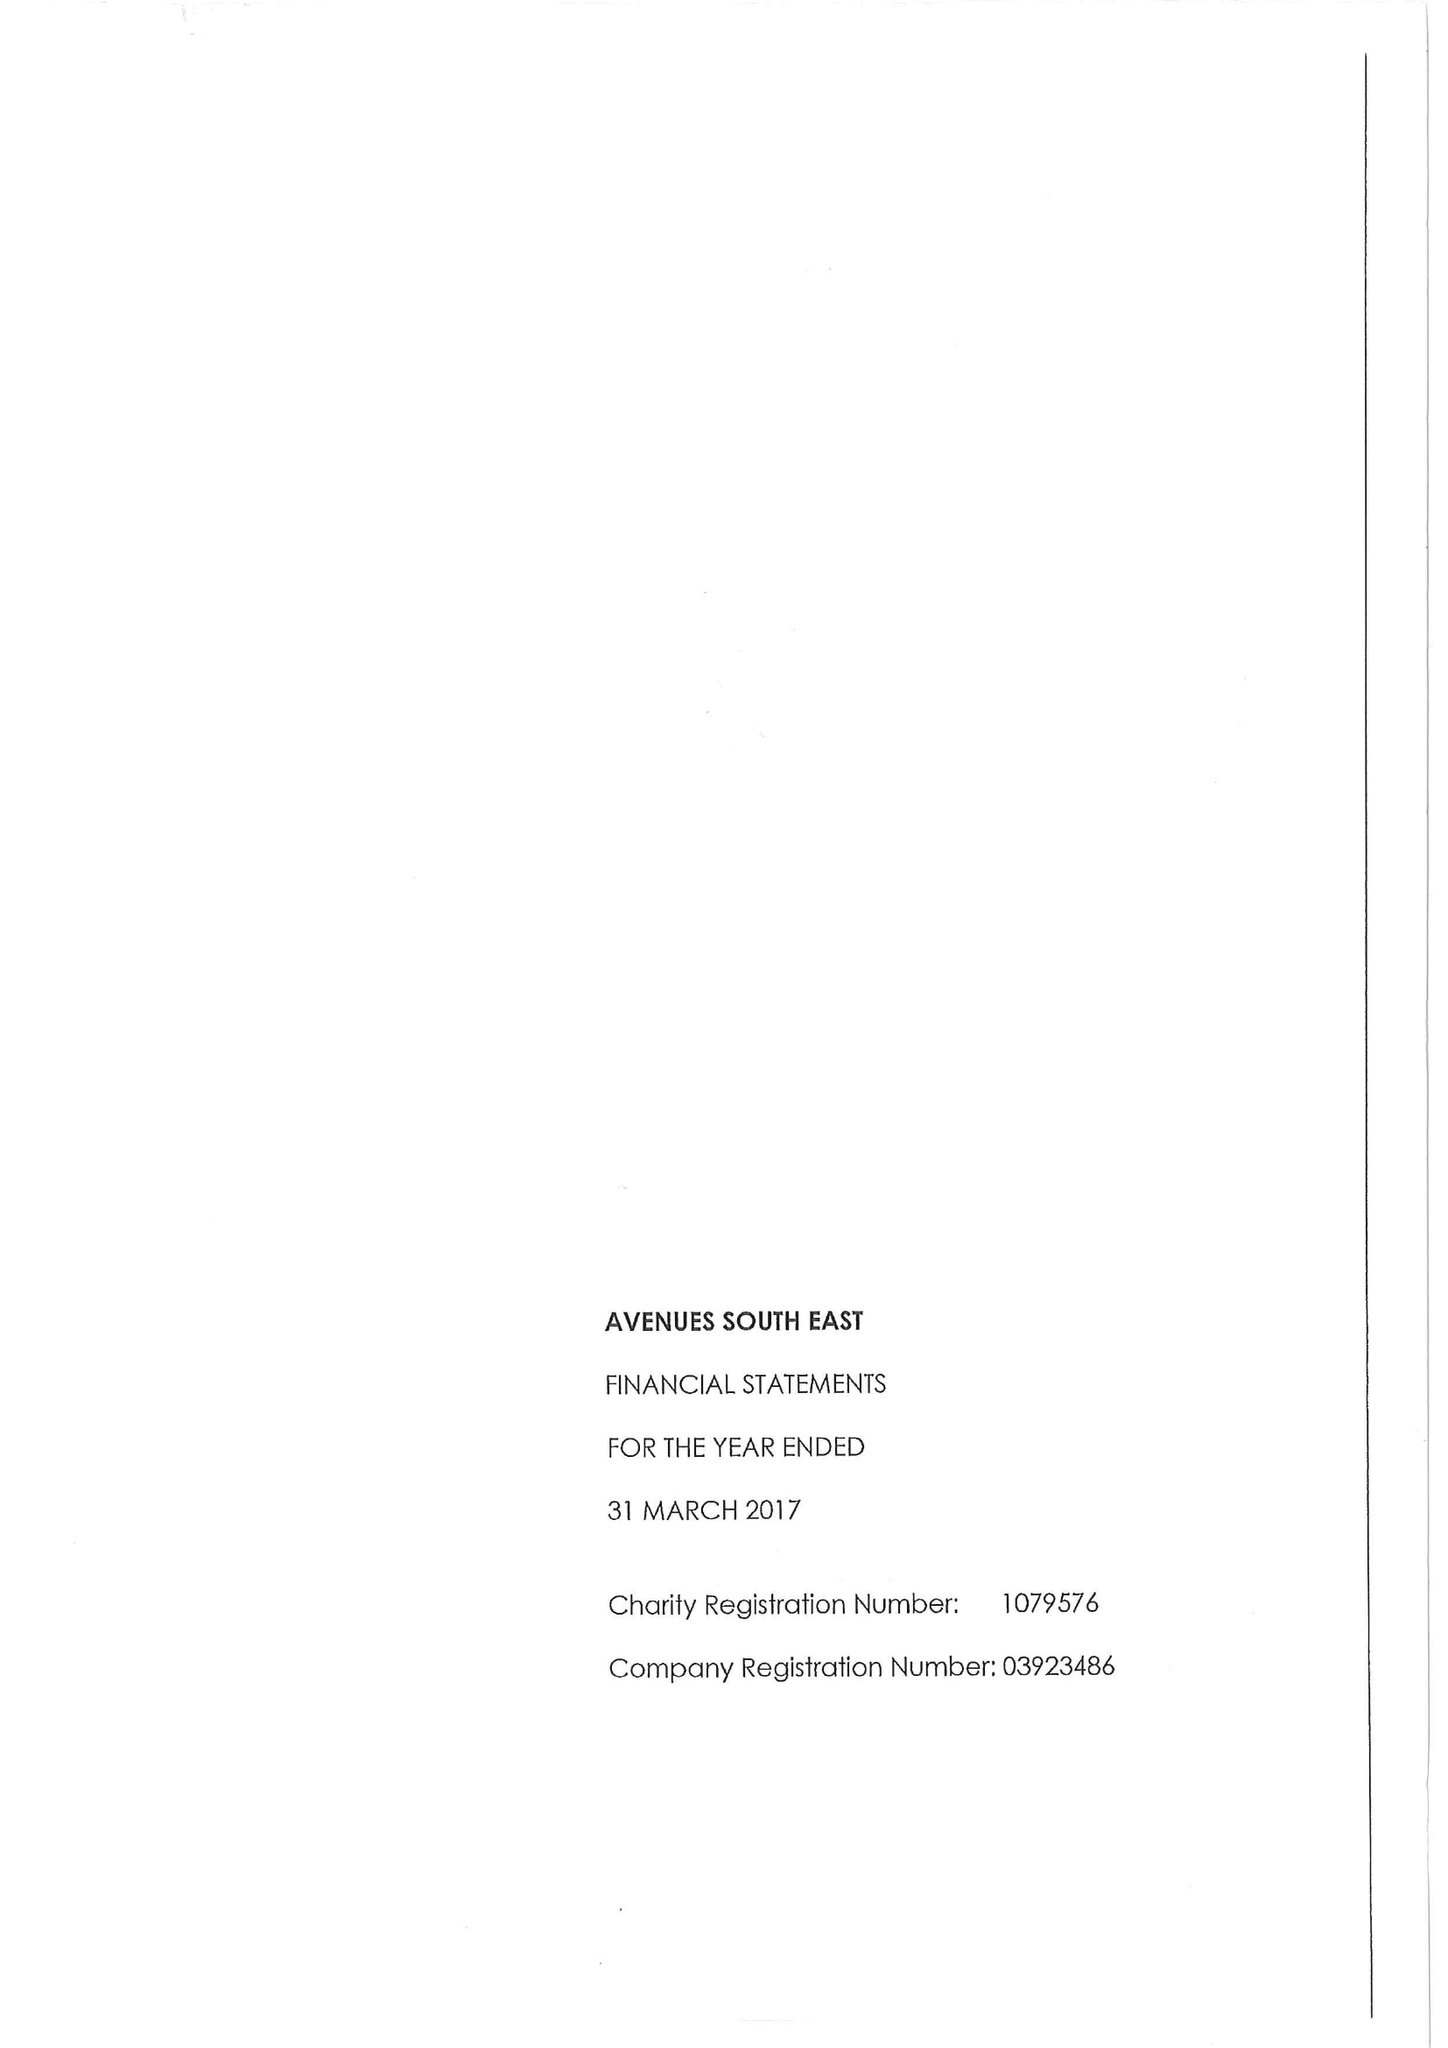What is the value for the charity_name?
Answer the question using a single word or phrase. Avenues South East 